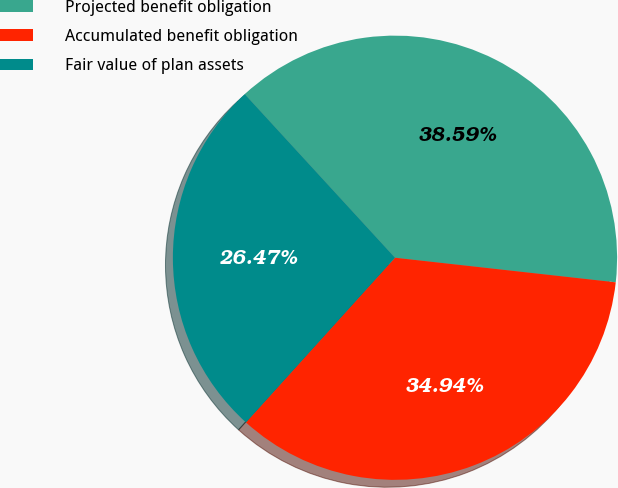Convert chart to OTSL. <chart><loc_0><loc_0><loc_500><loc_500><pie_chart><fcel>Projected benefit obligation<fcel>Accumulated benefit obligation<fcel>Fair value of plan assets<nl><fcel>38.59%<fcel>34.94%<fcel>26.47%<nl></chart> 